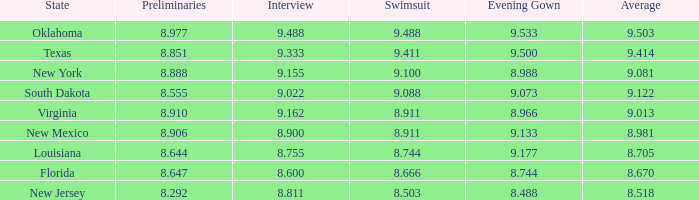What are the preliminaries in which the evening gown is 8.988? 8.888. Can you give me this table as a dict? {'header': ['State', 'Preliminaries', 'Interview', 'Swimsuit', 'Evening Gown', 'Average'], 'rows': [['Oklahoma', '8.977', '9.488', '9.488', '9.533', '9.503'], ['Texas', '8.851', '9.333', '9.411', '9.500', '9.414'], ['New York', '8.888', '9.155', '9.100', '8.988', '9.081'], ['South Dakota', '8.555', '9.022', '9.088', '9.073', '9.122'], ['Virginia', '8.910', '9.162', '8.911', '8.966', '9.013'], ['New Mexico', '8.906', '8.900', '8.911', '9.133', '8.981'], ['Louisiana', '8.644', '8.755', '8.744', '9.177', '8.705'], ['Florida', '8.647', '8.600', '8.666', '8.744', '8.670'], ['New Jersey', '8.292', '8.811', '8.503', '8.488', '8.518']]} 